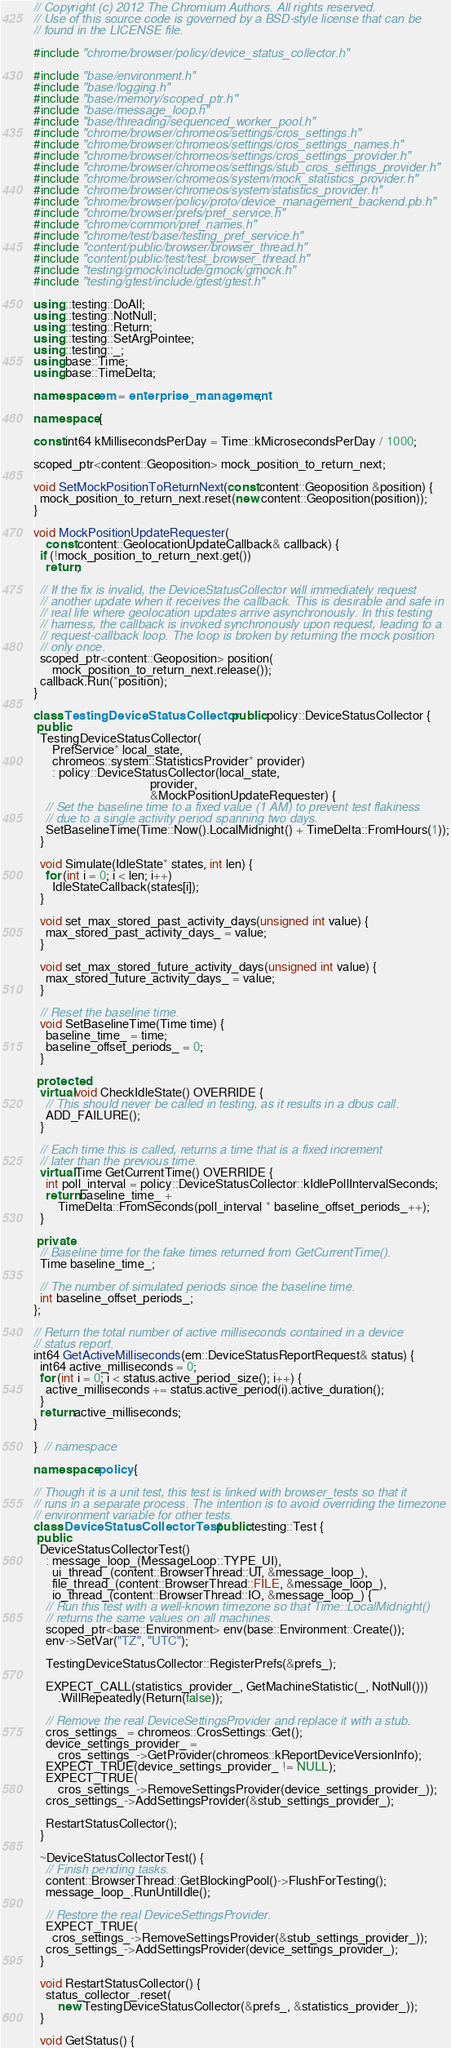Convert code to text. <code><loc_0><loc_0><loc_500><loc_500><_C++_>// Copyright (c) 2012 The Chromium Authors. All rights reserved.
// Use of this source code is governed by a BSD-style license that can be
// found in the LICENSE file.

#include "chrome/browser/policy/device_status_collector.h"

#include "base/environment.h"
#include "base/logging.h"
#include "base/memory/scoped_ptr.h"
#include "base/message_loop.h"
#include "base/threading/sequenced_worker_pool.h"
#include "chrome/browser/chromeos/settings/cros_settings.h"
#include "chrome/browser/chromeos/settings/cros_settings_names.h"
#include "chrome/browser/chromeos/settings/cros_settings_provider.h"
#include "chrome/browser/chromeos/settings/stub_cros_settings_provider.h"
#include "chrome/browser/chromeos/system/mock_statistics_provider.h"
#include "chrome/browser/chromeos/system/statistics_provider.h"
#include "chrome/browser/policy/proto/device_management_backend.pb.h"
#include "chrome/browser/prefs/pref_service.h"
#include "chrome/common/pref_names.h"
#include "chrome/test/base/testing_pref_service.h"
#include "content/public/browser/browser_thread.h"
#include "content/public/test/test_browser_thread.h"
#include "testing/gmock/include/gmock/gmock.h"
#include "testing/gtest/include/gtest/gtest.h"

using ::testing::DoAll;
using ::testing::NotNull;
using ::testing::Return;
using ::testing::SetArgPointee;
using ::testing::_;
using base::Time;
using base::TimeDelta;

namespace em = enterprise_management;

namespace {

const int64 kMillisecondsPerDay = Time::kMicrosecondsPerDay / 1000;

scoped_ptr<content::Geoposition> mock_position_to_return_next;

void SetMockPositionToReturnNext(const content::Geoposition &position) {
  mock_position_to_return_next.reset(new content::Geoposition(position));
}

void MockPositionUpdateRequester(
    const content::GeolocationUpdateCallback& callback) {
  if (!mock_position_to_return_next.get())
    return;

  // If the fix is invalid, the DeviceStatusCollector will immediately request
  // another update when it receives the callback. This is desirable and safe in
  // real life where geolocation updates arrive asynchronously. In this testing
  // harness, the callback is invoked synchronously upon request, leading to a
  // request-callback loop. The loop is broken by returning the mock position
  // only once.
  scoped_ptr<content::Geoposition> position(
      mock_position_to_return_next.release());
  callback.Run(*position);
}

class TestingDeviceStatusCollector : public policy::DeviceStatusCollector {
 public:
  TestingDeviceStatusCollector(
      PrefService* local_state,
      chromeos::system::StatisticsProvider* provider)
      : policy::DeviceStatusCollector(local_state,
                                      provider,
                                      &MockPositionUpdateRequester) {
    // Set the baseline time to a fixed value (1 AM) to prevent test flakiness
    // due to a single activity period spanning two days.
    SetBaselineTime(Time::Now().LocalMidnight() + TimeDelta::FromHours(1));
  }

  void Simulate(IdleState* states, int len) {
    for (int i = 0; i < len; i++)
      IdleStateCallback(states[i]);
  }

  void set_max_stored_past_activity_days(unsigned int value) {
    max_stored_past_activity_days_ = value;
  }

  void set_max_stored_future_activity_days(unsigned int value) {
    max_stored_future_activity_days_ = value;
  }

  // Reset the baseline time.
  void SetBaselineTime(Time time) {
    baseline_time_ = time;
    baseline_offset_periods_ = 0;
  }

 protected:
  virtual void CheckIdleState() OVERRIDE {
    // This should never be called in testing, as it results in a dbus call.
    ADD_FAILURE();
  }

  // Each time this is called, returns a time that is a fixed increment
  // later than the previous time.
  virtual Time GetCurrentTime() OVERRIDE {
    int poll_interval = policy::DeviceStatusCollector::kIdlePollIntervalSeconds;
    return baseline_time_ +
        TimeDelta::FromSeconds(poll_interval * baseline_offset_periods_++);
  }

 private:
  // Baseline time for the fake times returned from GetCurrentTime().
  Time baseline_time_;

  // The number of simulated periods since the baseline time.
  int baseline_offset_periods_;
};

// Return the total number of active milliseconds contained in a device
// status report.
int64 GetActiveMilliseconds(em::DeviceStatusReportRequest& status) {
  int64 active_milliseconds = 0;
  for (int i = 0; i < status.active_period_size(); i++) {
    active_milliseconds += status.active_period(i).active_duration();
  }
  return active_milliseconds;
}

}  // namespace

namespace policy {

// Though it is a unit test, this test is linked with browser_tests so that it
// runs in a separate process. The intention is to avoid overriding the timezone
// environment variable for other tests.
class DeviceStatusCollectorTest : public testing::Test {
 public:
  DeviceStatusCollectorTest()
    : message_loop_(MessageLoop::TYPE_UI),
      ui_thread_(content::BrowserThread::UI, &message_loop_),
      file_thread_(content::BrowserThread::FILE, &message_loop_),
      io_thread_(content::BrowserThread::IO, &message_loop_) {
    // Run this test with a well-known timezone so that Time::LocalMidnight()
    // returns the same values on all machines.
    scoped_ptr<base::Environment> env(base::Environment::Create());
    env->SetVar("TZ", "UTC");

    TestingDeviceStatusCollector::RegisterPrefs(&prefs_);

    EXPECT_CALL(statistics_provider_, GetMachineStatistic(_, NotNull()))
        .WillRepeatedly(Return(false));

    // Remove the real DeviceSettingsProvider and replace it with a stub.
    cros_settings_ = chromeos::CrosSettings::Get();
    device_settings_provider_ =
        cros_settings_->GetProvider(chromeos::kReportDeviceVersionInfo);
    EXPECT_TRUE(device_settings_provider_ != NULL);
    EXPECT_TRUE(
        cros_settings_->RemoveSettingsProvider(device_settings_provider_));
    cros_settings_->AddSettingsProvider(&stub_settings_provider_);

    RestartStatusCollector();
  }

  ~DeviceStatusCollectorTest() {
    // Finish pending tasks.
    content::BrowserThread::GetBlockingPool()->FlushForTesting();
    message_loop_.RunUntilIdle();

    // Restore the real DeviceSettingsProvider.
    EXPECT_TRUE(
      cros_settings_->RemoveSettingsProvider(&stub_settings_provider_));
    cros_settings_->AddSettingsProvider(device_settings_provider_);
  }

  void RestartStatusCollector() {
    status_collector_.reset(
        new TestingDeviceStatusCollector(&prefs_, &statistics_provider_));
  }

  void GetStatus() {</code> 